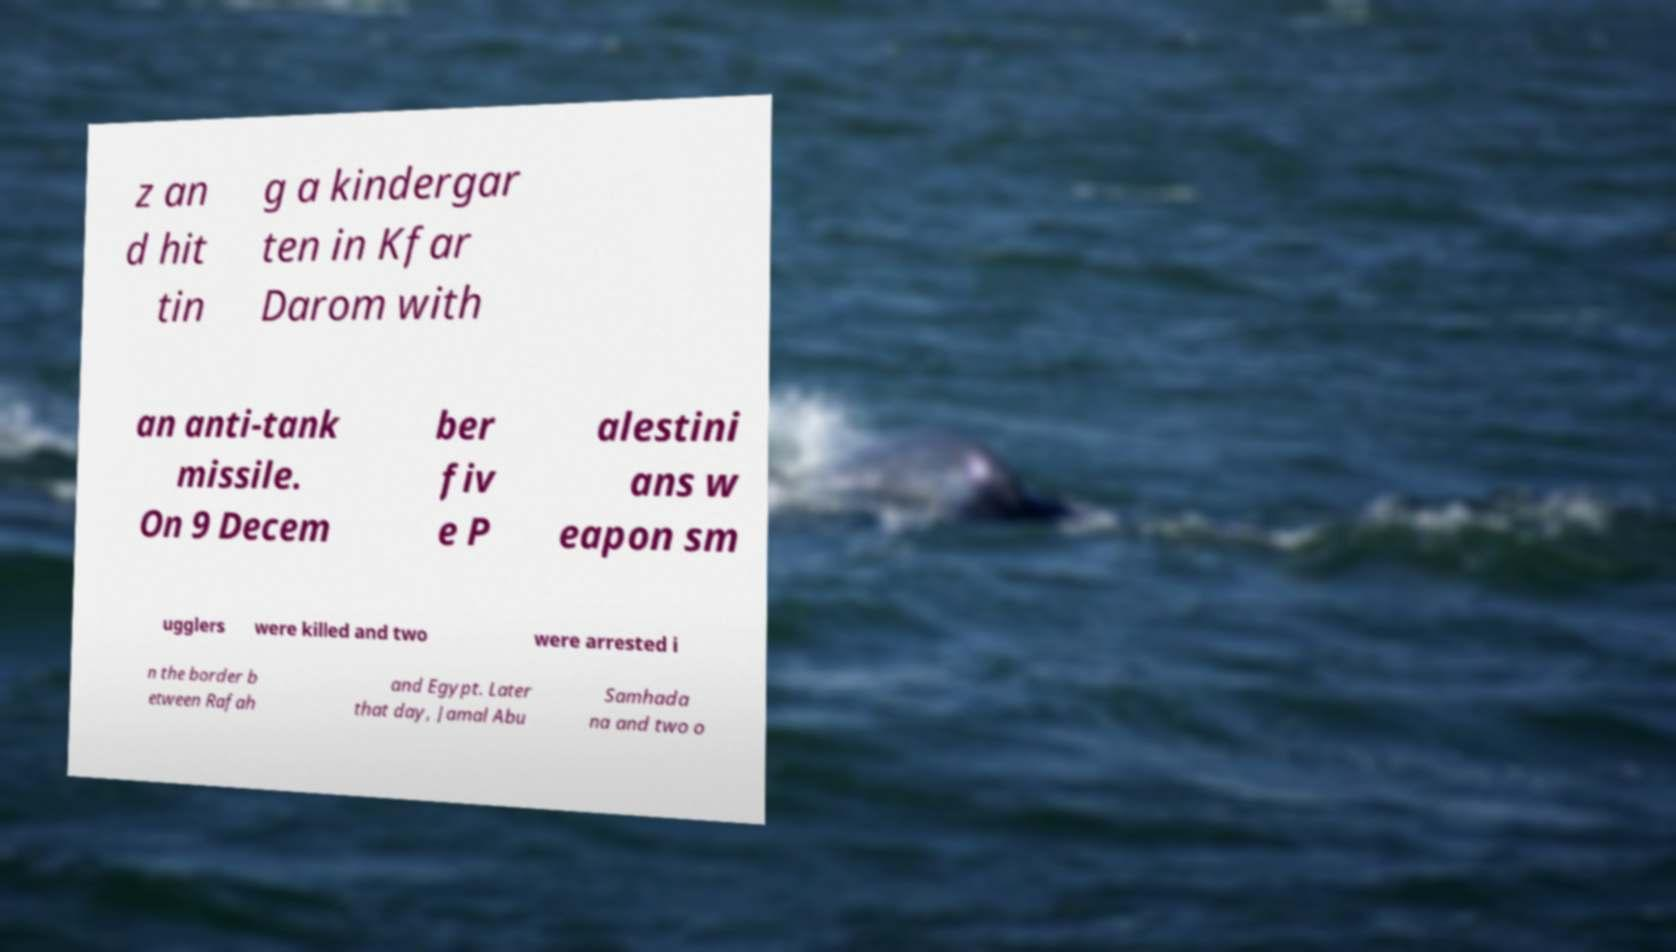Can you accurately transcribe the text from the provided image for me? z an d hit tin g a kindergar ten in Kfar Darom with an anti-tank missile. On 9 Decem ber fiv e P alestini ans w eapon sm ugglers were killed and two were arrested i n the border b etween Rafah and Egypt. Later that day, Jamal Abu Samhada na and two o 